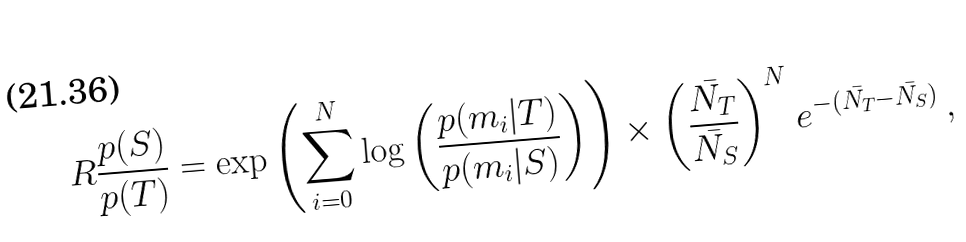<formula> <loc_0><loc_0><loc_500><loc_500>R \frac { p ( S ) } { p ( T ) } = \exp { \left ( \sum _ { i = 0 } ^ { N } \log \left ( \frac { p ( m _ { i } | T ) } { p ( m _ { i } | S ) } \right ) \right ) } \times \left ( \frac { \bar { N _ { T } } } { \bar { N _ { S } } } \right ) ^ { N } e ^ { - ( \bar { N _ { T } } - \bar { N _ { S } } ) } \, ,</formula> 